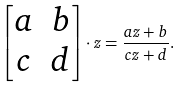Convert formula to latex. <formula><loc_0><loc_0><loc_500><loc_500>\begin{bmatrix} a & b \\ c & d \end{bmatrix} \cdot z = \frac { a z + b } { c z + d } .</formula> 